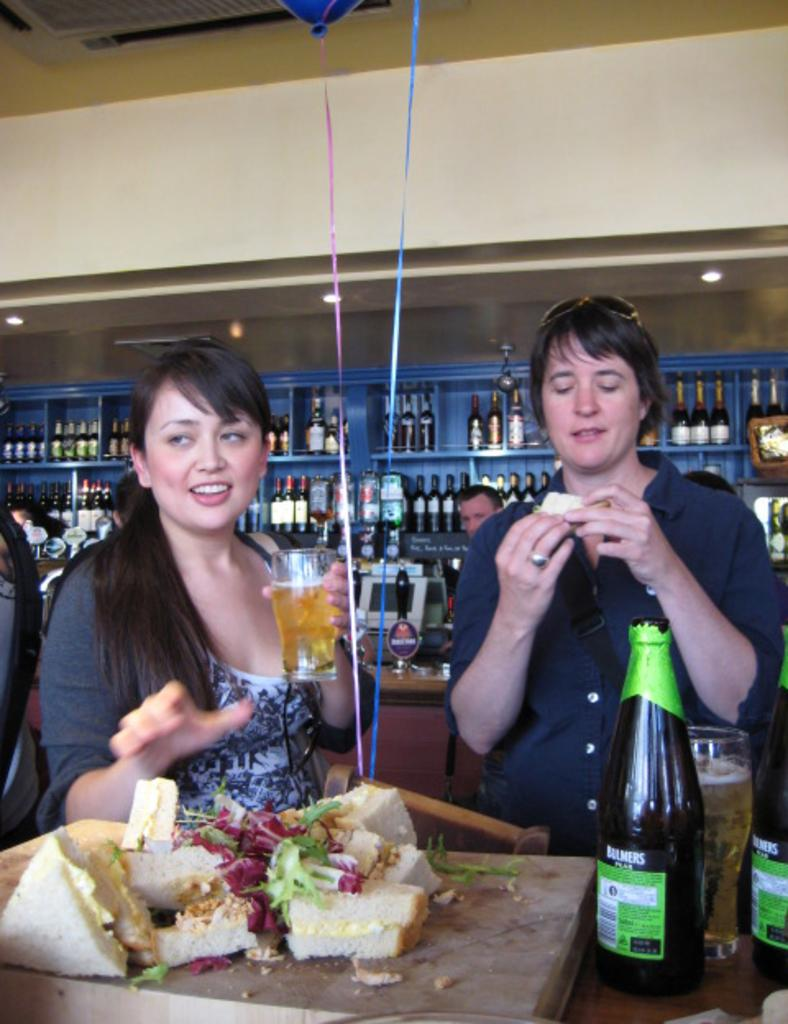<image>
Provide a brief description of the given image. Two woman drinking Bulmers beer and eating sandwiches 